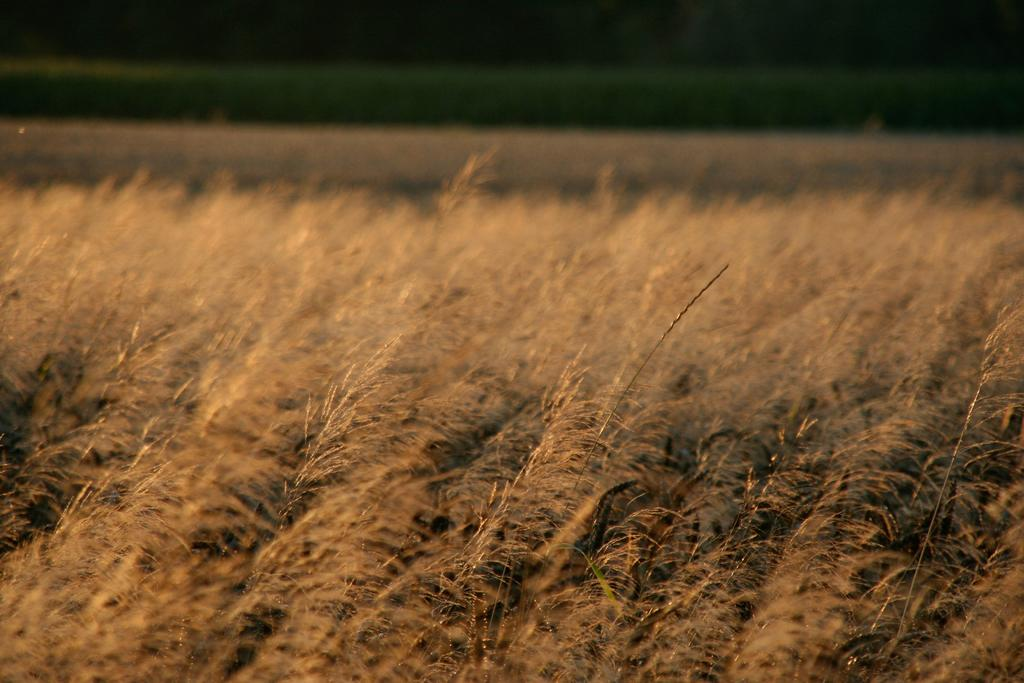What type of vegetation is visible in the image? There is grass in the image. Can you describe the background of the image? The background of the image is blurry. What type of acoustics can be heard in the image? There is no sound or acoustics present in the image, as it is a still image. Can you see a wrench being used in the image? There is no wrench or any tool visible in the image; it only features grass and a blurry background. 